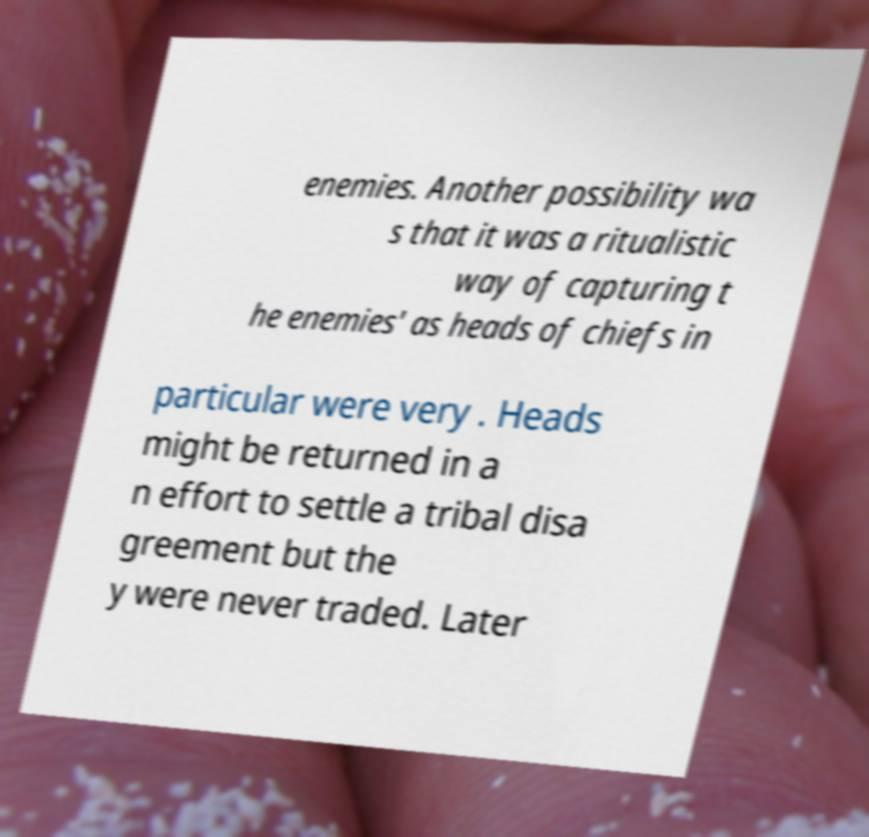For documentation purposes, I need the text within this image transcribed. Could you provide that? enemies. Another possibility wa s that it was a ritualistic way of capturing t he enemies' as heads of chiefs in particular were very . Heads might be returned in a n effort to settle a tribal disa greement but the y were never traded. Later 